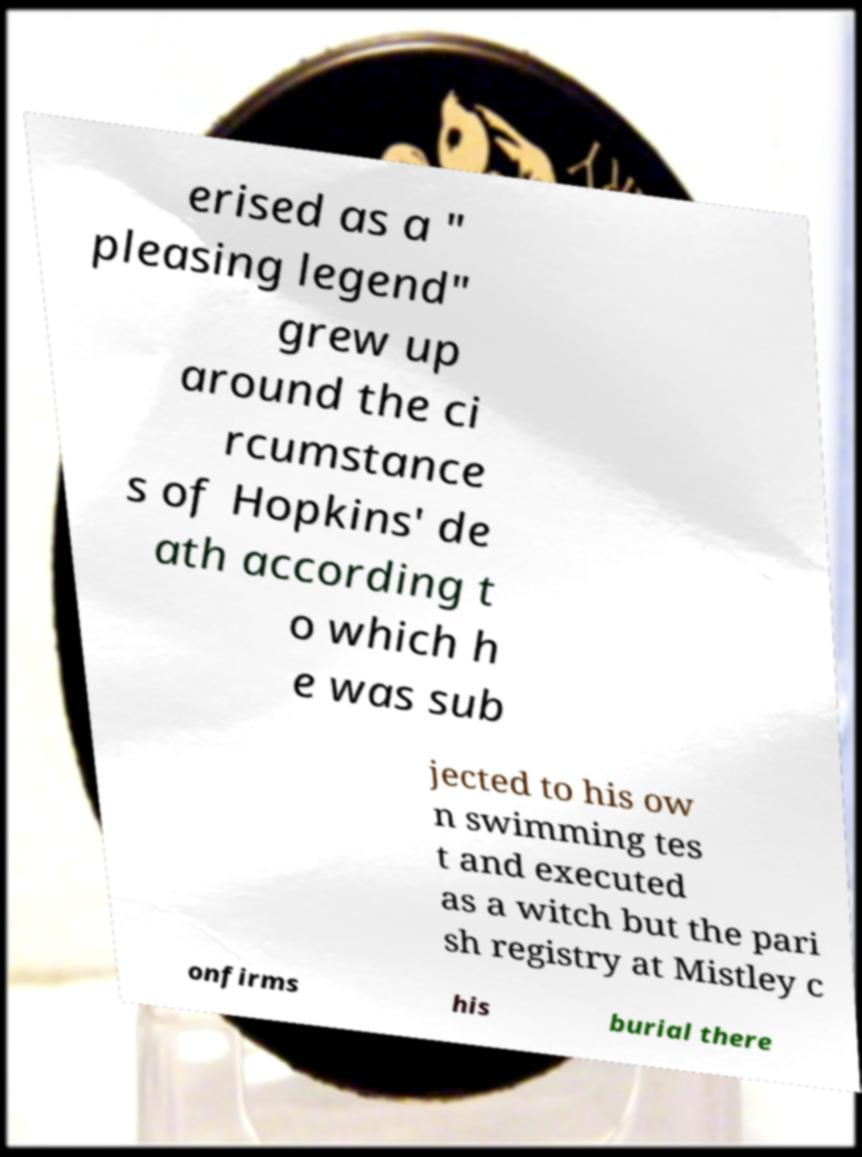Can you read and provide the text displayed in the image?This photo seems to have some interesting text. Can you extract and type it out for me? erised as a " pleasing legend" grew up around the ci rcumstance s of Hopkins' de ath according t o which h e was sub jected to his ow n swimming tes t and executed as a witch but the pari sh registry at Mistley c onfirms his burial there 